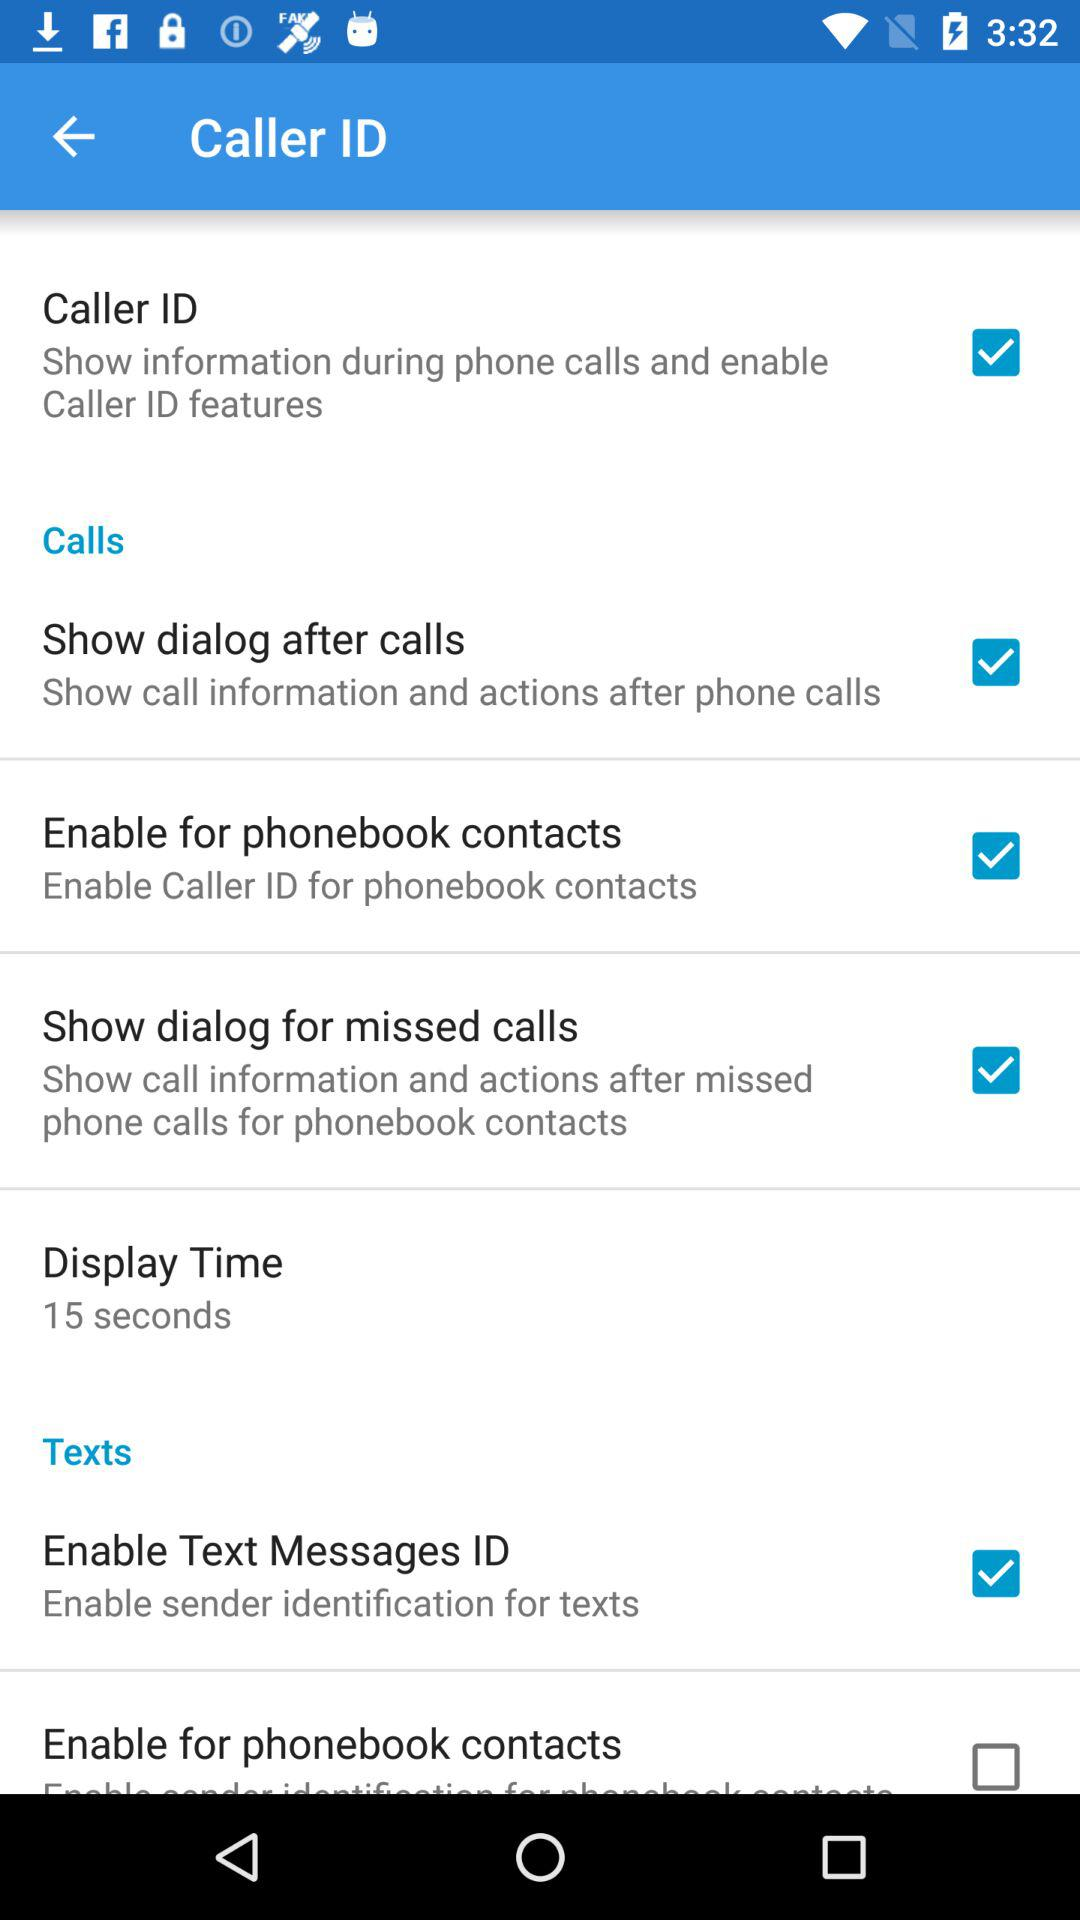What is the current status of "Show dialog after calls"? The current status of "Show dialog after calls" is "on". 